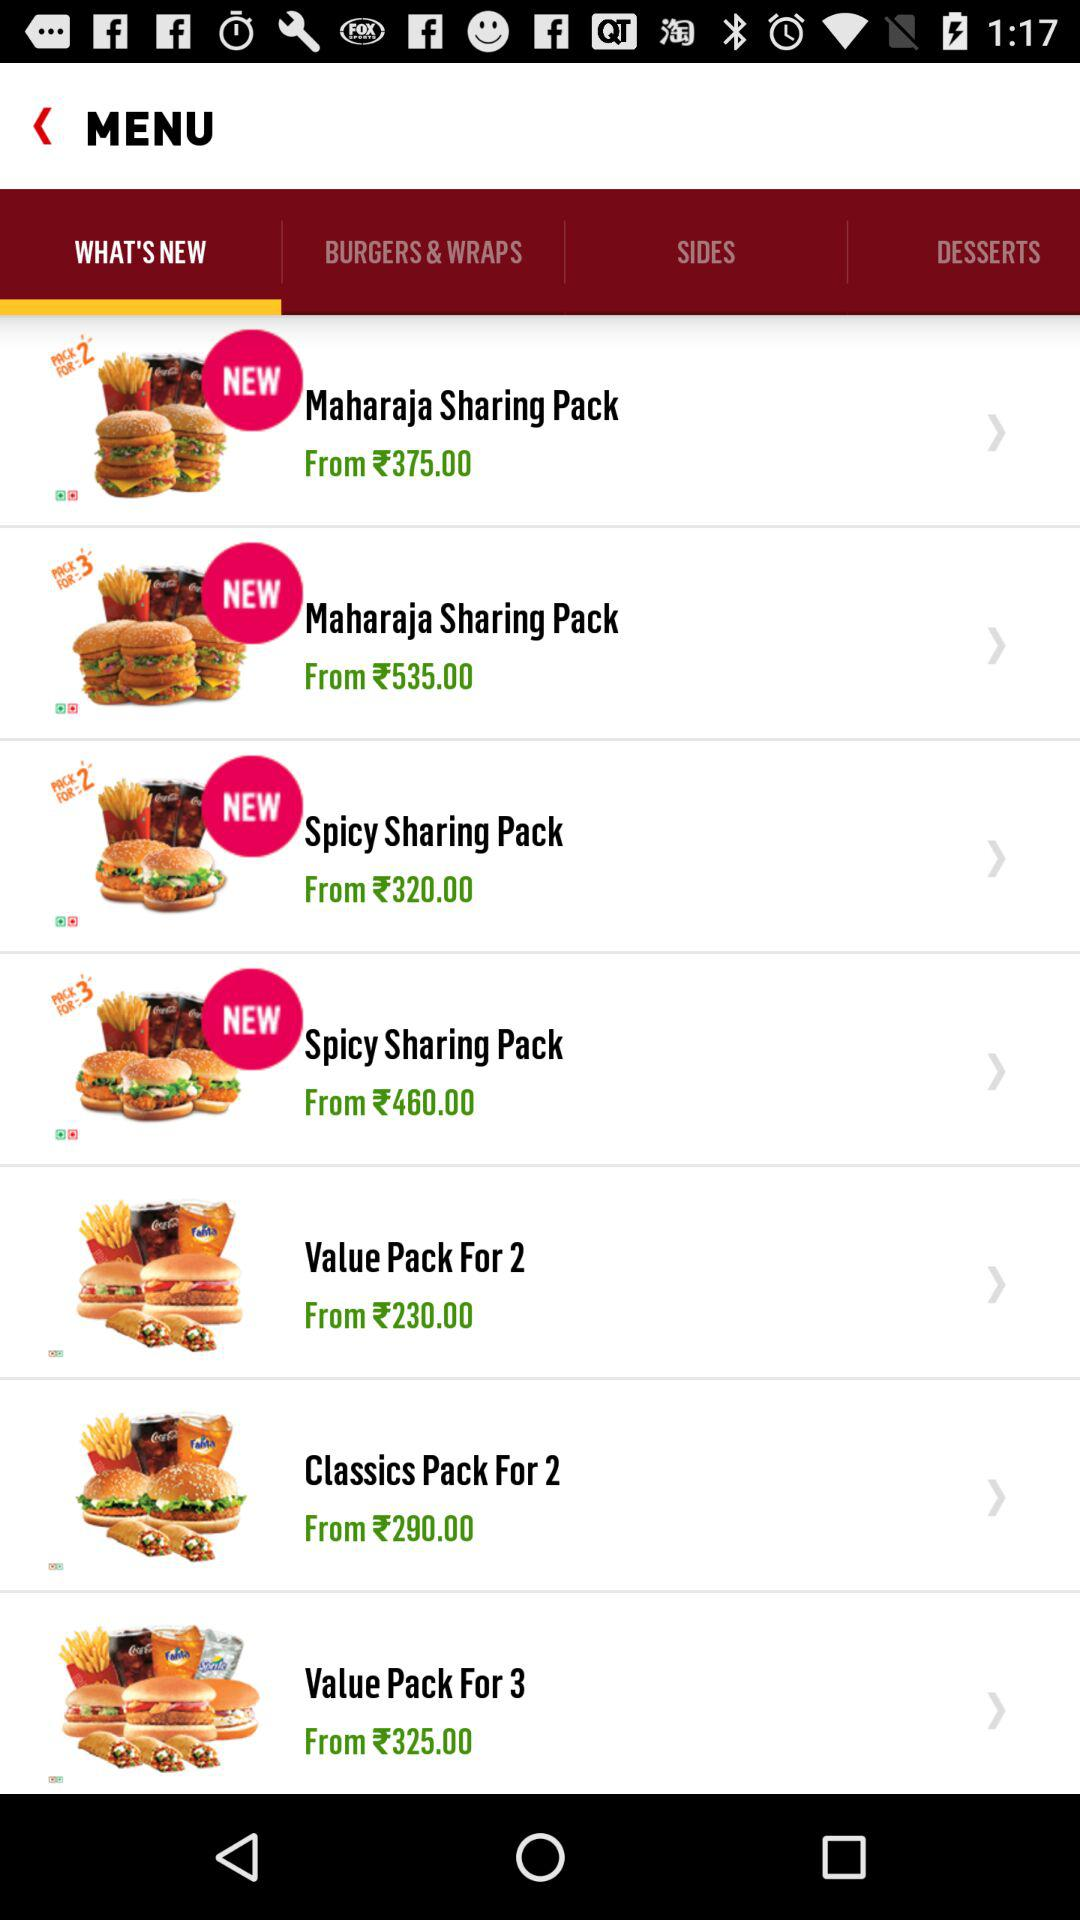What is the price of a "Value Pack For 2"? The price of a "Value Pack For 2" starts at ₹230. 